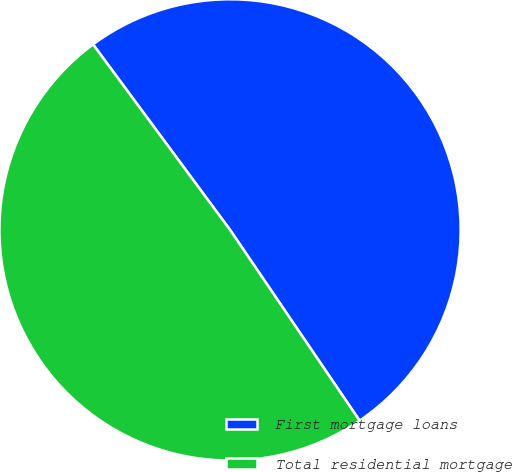<chart> <loc_0><loc_0><loc_500><loc_500><pie_chart><fcel>First mortgage loans<fcel>Total residential mortgage<nl><fcel>50.63%<fcel>49.37%<nl></chart> 